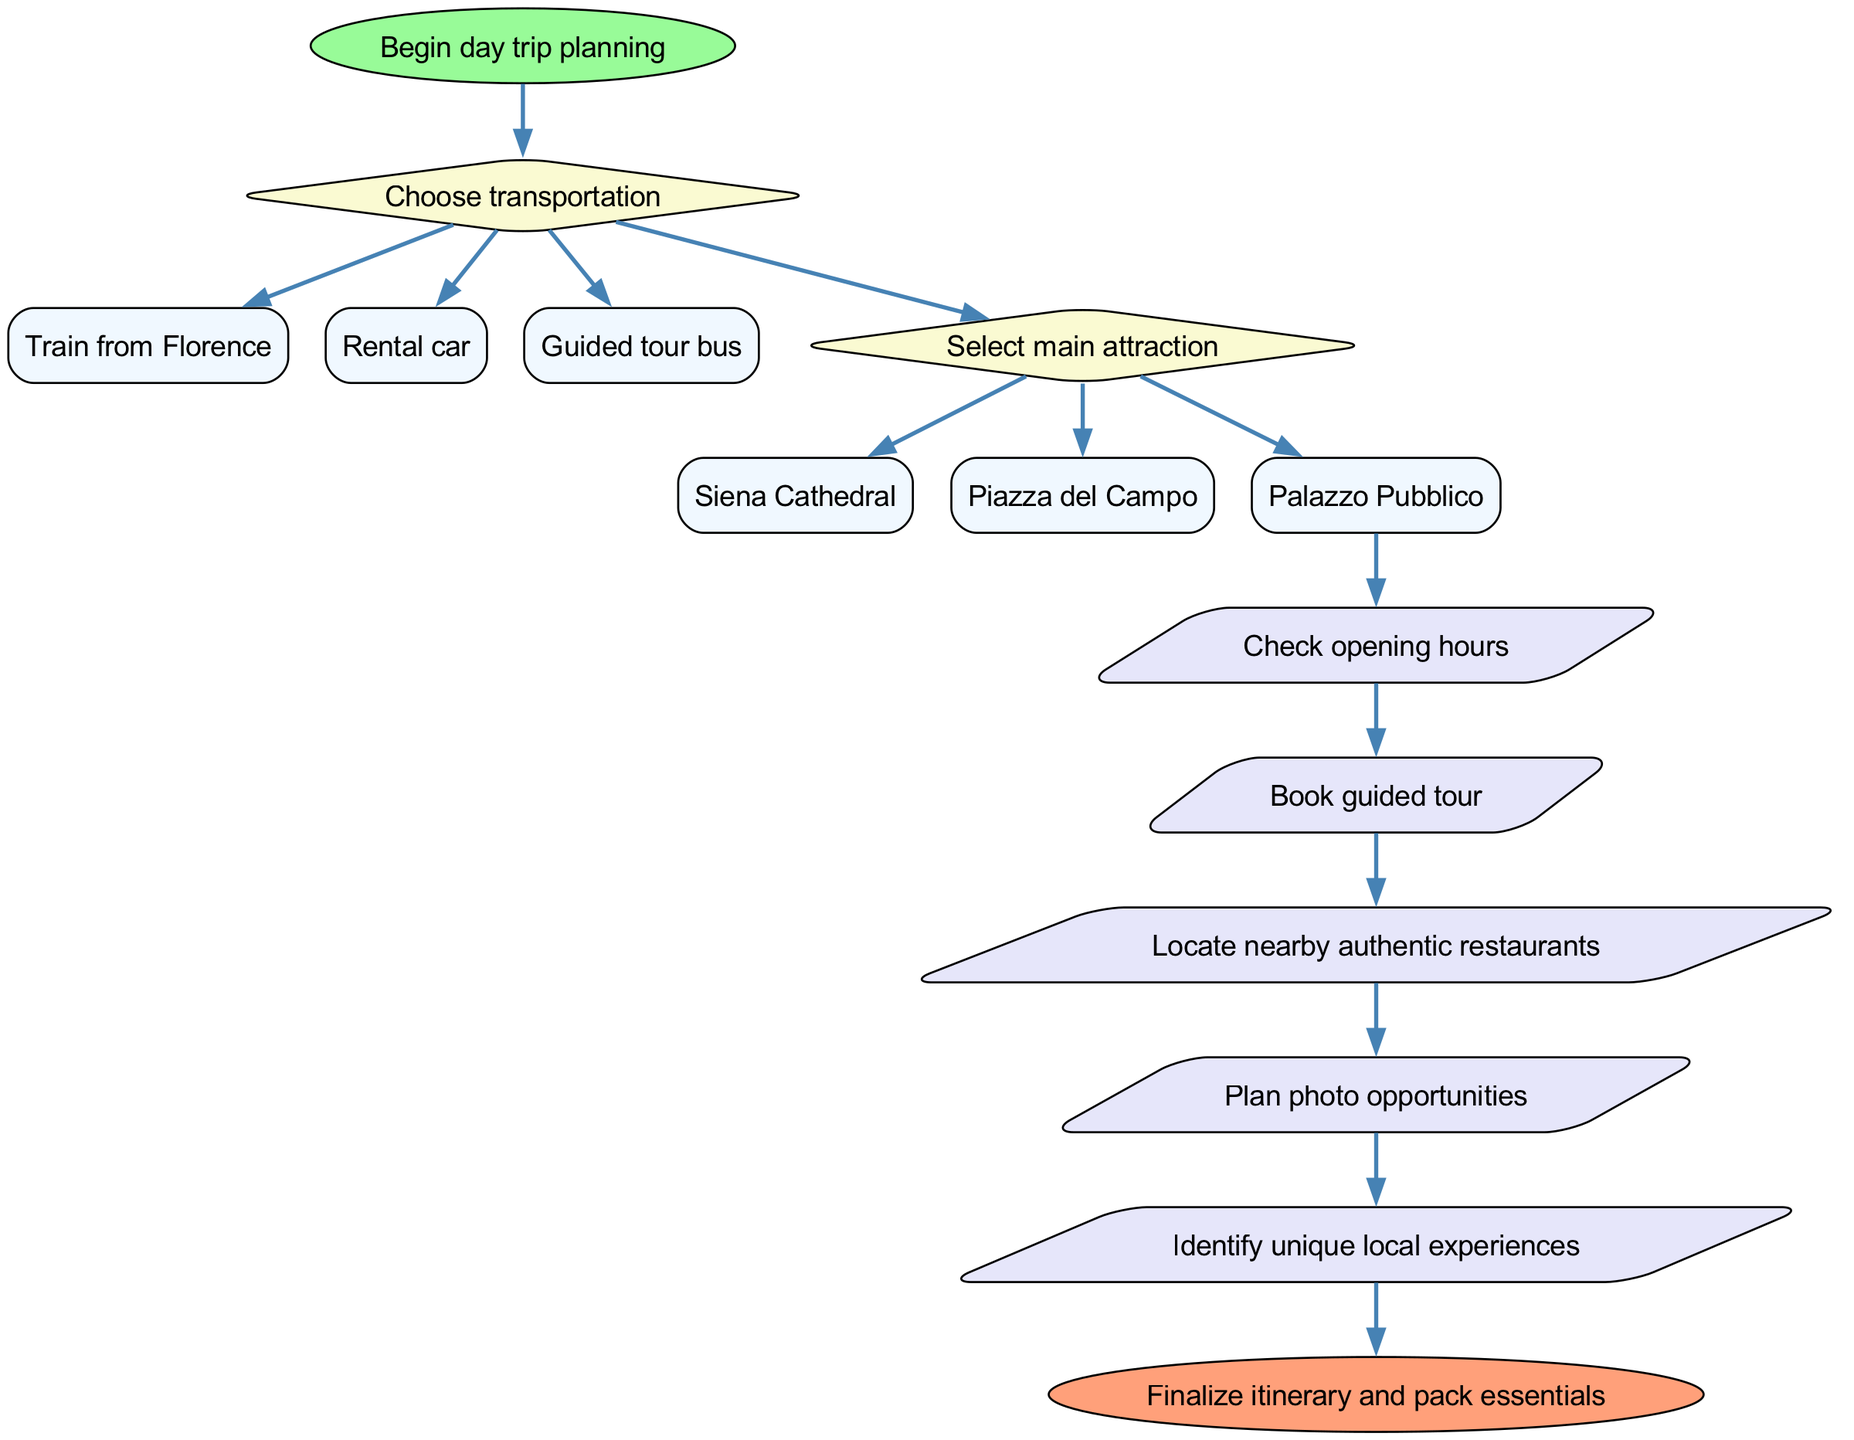What is the first step in planning the day trip? The first step indicated in the diagram is "Begin day trip planning," which serves as the starting point of the process.
Answer: Begin day trip planning How many transportation options are listed? There are three options provided under the "Choose transportation" decision: Train from Florence, Rental car, and Guided tour bus, totaling three options.
Answer: 3 What is the shape of the end node? The end node in the diagram is shaped like an ellipse, as indicated by its description in the code.
Answer: ellipse Which attraction comes after choosing the transportation? After choosing transportation, the next step is to "Select main attraction," which follows the decision node for transportation in the flow.
Answer: Select main attraction What action follows checking opening hours? After "Check opening hours," the next action in the flow is "Book guided tour," making it the subsequent step to take.
Answer: Book guided tour What is the last action before finalizing the itinerary? The final action before reaching the end of the process is "Identify unique local experiences," which is the last step in the action series.
Answer: Identify unique local experiences Which transportation option leads directly to checking opening hours? The option "Guided tour bus" leads directly to checking opening hours; this is the last option under the transportation decision that flows into the actions.
Answer: Guided tour bus What is the relationship between selecting an attraction and locating restaurants? After selecting a main attraction, both "Locate nearby authentic restaurants" and other action nodes follow sequentially; this indicates they are steps to be taken after the attraction is selected.
Answer: Sequential steps What is the final step in this planning flow? The final step illustrated in the diagram is "Finalize itinerary and pack essentials," marking the conclusion of the planning process.
Answer: Finalize itinerary and pack essentials 